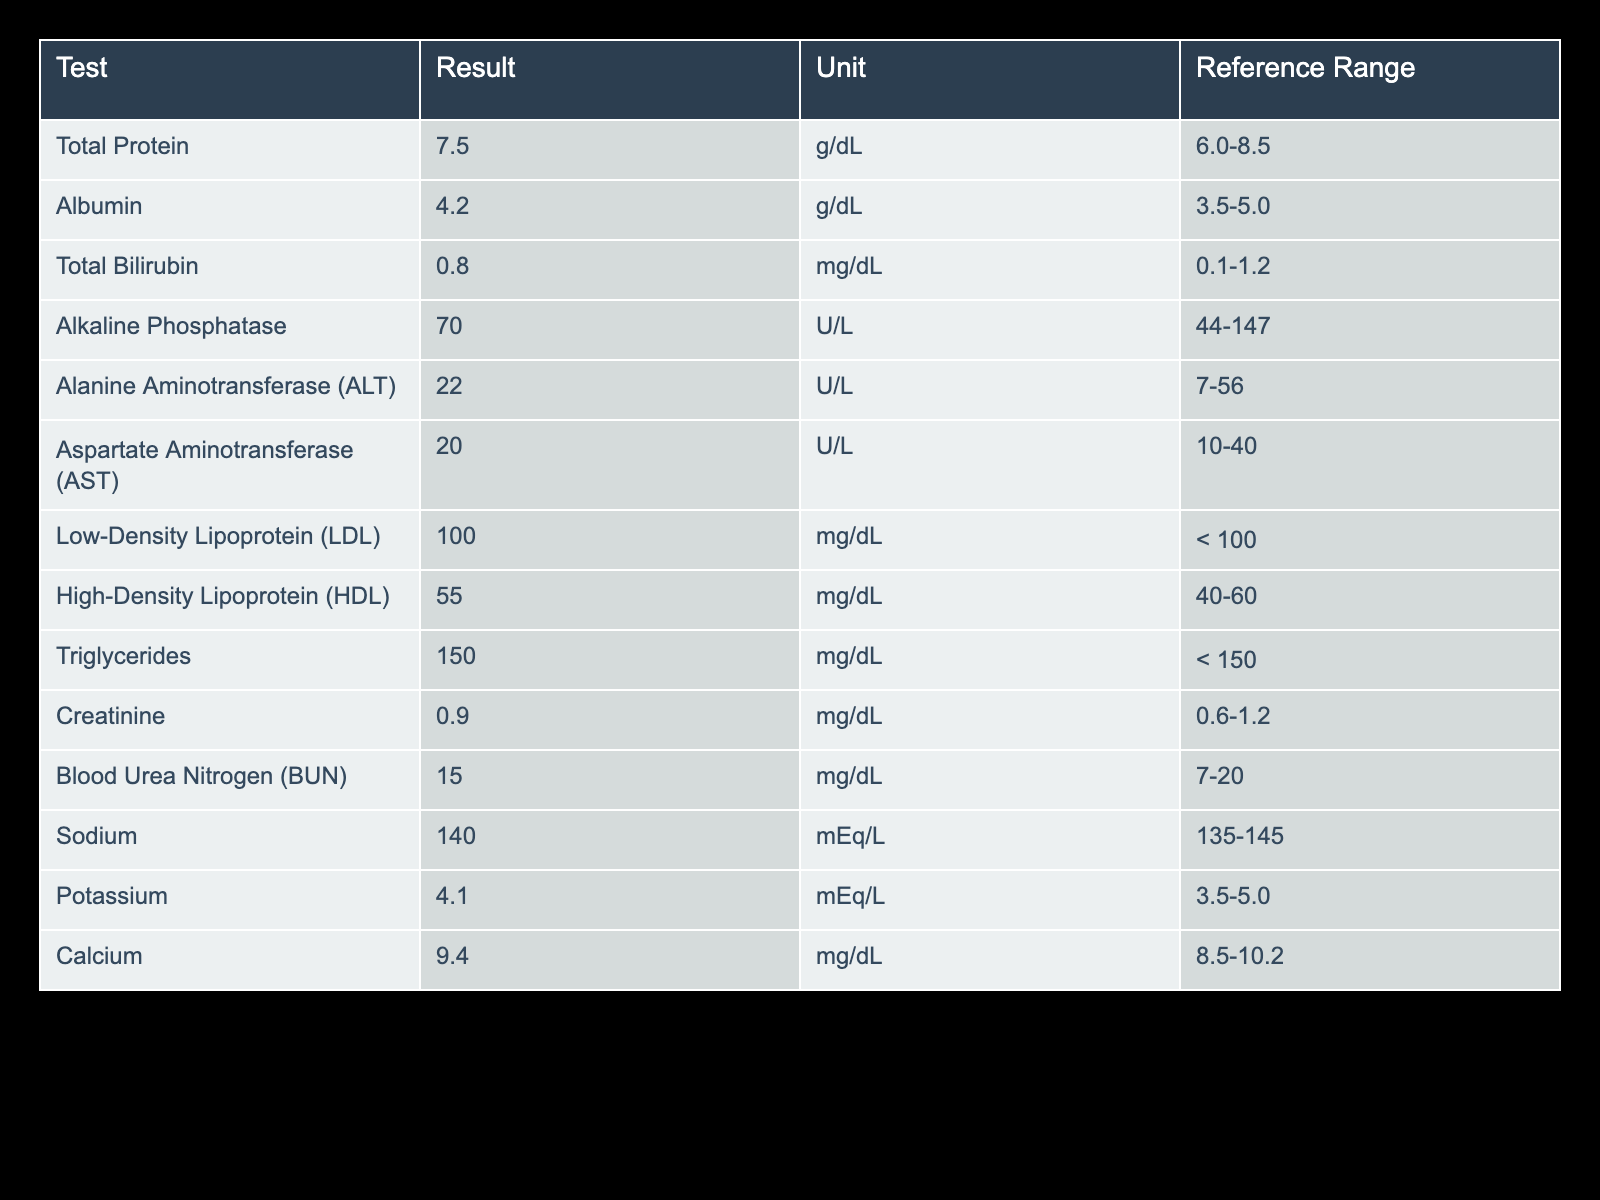What is the result of the Total Bilirubin test? The result for Total Bilirubin in the table is listed under the "Result" column. Looking at that column, I see the value for Total Bilirubin is 0.8 mg/dL.
Answer: 0.8 mg/dL Is the Potassium level within the reference range? The reference range for Potassium is 3.5-5.0 mEq/L. The result in the table shows a Potassium level of 4.1 mEq/L, which falls within this range.
Answer: Yes What is the difference between the Total Protein and Albumin levels? To find the difference, I subtract the Albumin value from the Total Protein value: 7.5 g/dL (Total Protein) - 4.2 g/dL (Albumin) = 3.3 g/dL.
Answer: 3.3 g/dL Is the Low-Density Lipoprotein (LDL) level considered optimal for healthy adults? The table indicates the LDL result as 100 mg/dL, and it also notes that the ideal level is less than 100 mg/dL. Therefore, 100 mg/dL is at the upper threshold, which is not optimal.
Answer: No What is the average value of the Triglycerides and HDL levels? The values for Triglycerides and HDL are 150 mg/dL and 55 mg/dL, respectively. The average is calculated as (150 + 55) / 2 = 102.5 mg/dL.
Answer: 102.5 mg/dL How many tests in the panel have results outside of their reference ranges? I must first compare each test result with its corresponding reference range. The LDL (100 mg/dL) and Triglycerides (150 mg/dL) both fall at the boundary of their ranges and are not outside. All other tests fall within their ranges, resulting in a total of zero tests outside the reference ranges.
Answer: 0 Is the Creatinine level at a healthy level according to the reference range? The reference range for Creatinine is 0.6-1.2 mg/dL, and the table shows that the Creatinine level is 0.9 mg/dL, which falls within this range.
Answer: Yes What is the maximum value for Alkaline Phosphatase in this panel? Looking at the reference range for Alkaline Phosphatase, which is stated as 44-147 U/L, the maximum value specified is 147 U/L. This is the highest value allowed for healthy adults.
Answer: 147 U/L 